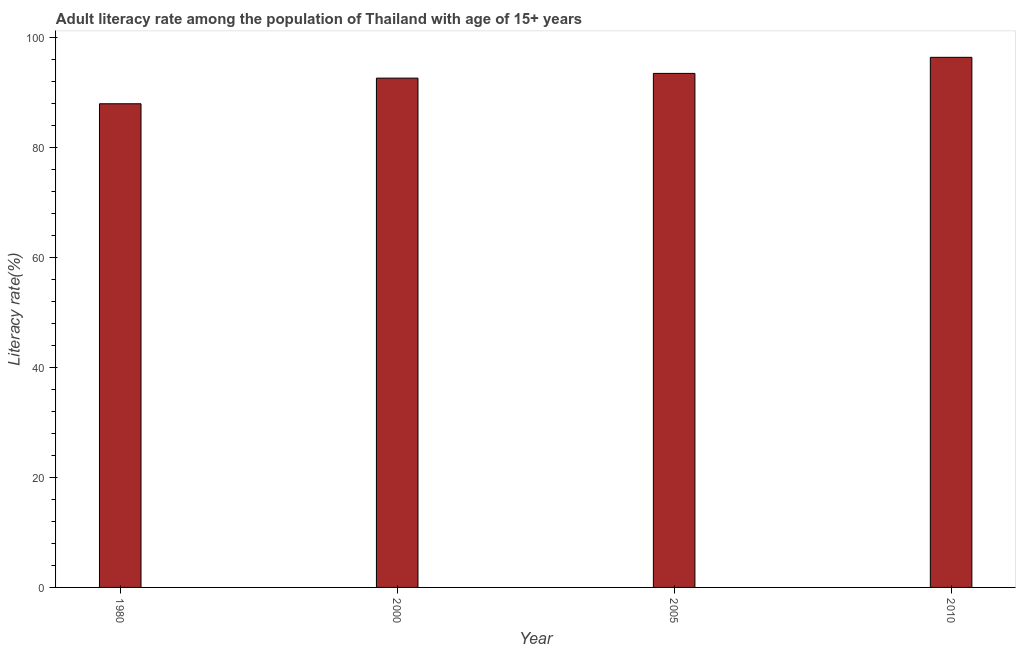Does the graph contain any zero values?
Your answer should be very brief. No. What is the title of the graph?
Provide a short and direct response. Adult literacy rate among the population of Thailand with age of 15+ years. What is the label or title of the X-axis?
Your answer should be compact. Year. What is the label or title of the Y-axis?
Your response must be concise. Literacy rate(%). What is the adult literacy rate in 1980?
Keep it short and to the point. 87.98. Across all years, what is the maximum adult literacy rate?
Give a very brief answer. 96.43. Across all years, what is the minimum adult literacy rate?
Your response must be concise. 87.98. In which year was the adult literacy rate maximum?
Offer a very short reply. 2010. What is the sum of the adult literacy rate?
Give a very brief answer. 370.57. What is the difference between the adult literacy rate in 1980 and 2000?
Offer a terse response. -4.67. What is the average adult literacy rate per year?
Provide a short and direct response. 92.64. What is the median adult literacy rate?
Give a very brief answer. 93.08. Do a majority of the years between 2000 and 1980 (inclusive) have adult literacy rate greater than 68 %?
Keep it short and to the point. No. What is the ratio of the adult literacy rate in 1980 to that in 2005?
Ensure brevity in your answer.  0.94. Is the difference between the adult literacy rate in 2000 and 2005 greater than the difference between any two years?
Make the answer very short. No. What is the difference between the highest and the second highest adult literacy rate?
Make the answer very short. 2.92. Is the sum of the adult literacy rate in 2000 and 2010 greater than the maximum adult literacy rate across all years?
Provide a succinct answer. Yes. What is the difference between the highest and the lowest adult literacy rate?
Offer a terse response. 8.45. How many years are there in the graph?
Your response must be concise. 4. What is the difference between two consecutive major ticks on the Y-axis?
Ensure brevity in your answer.  20. What is the Literacy rate(%) of 1980?
Provide a short and direct response. 87.98. What is the Literacy rate(%) of 2000?
Ensure brevity in your answer.  92.65. What is the Literacy rate(%) in 2005?
Ensure brevity in your answer.  93.51. What is the Literacy rate(%) of 2010?
Keep it short and to the point. 96.43. What is the difference between the Literacy rate(%) in 1980 and 2000?
Keep it short and to the point. -4.66. What is the difference between the Literacy rate(%) in 1980 and 2005?
Keep it short and to the point. -5.52. What is the difference between the Literacy rate(%) in 1980 and 2010?
Offer a terse response. -8.45. What is the difference between the Literacy rate(%) in 2000 and 2005?
Offer a very short reply. -0.86. What is the difference between the Literacy rate(%) in 2000 and 2010?
Your answer should be compact. -3.78. What is the difference between the Literacy rate(%) in 2005 and 2010?
Provide a short and direct response. -2.92. What is the ratio of the Literacy rate(%) in 1980 to that in 2000?
Make the answer very short. 0.95. What is the ratio of the Literacy rate(%) in 1980 to that in 2005?
Offer a terse response. 0.94. What is the ratio of the Literacy rate(%) in 1980 to that in 2010?
Your answer should be compact. 0.91. What is the ratio of the Literacy rate(%) in 2005 to that in 2010?
Offer a very short reply. 0.97. 